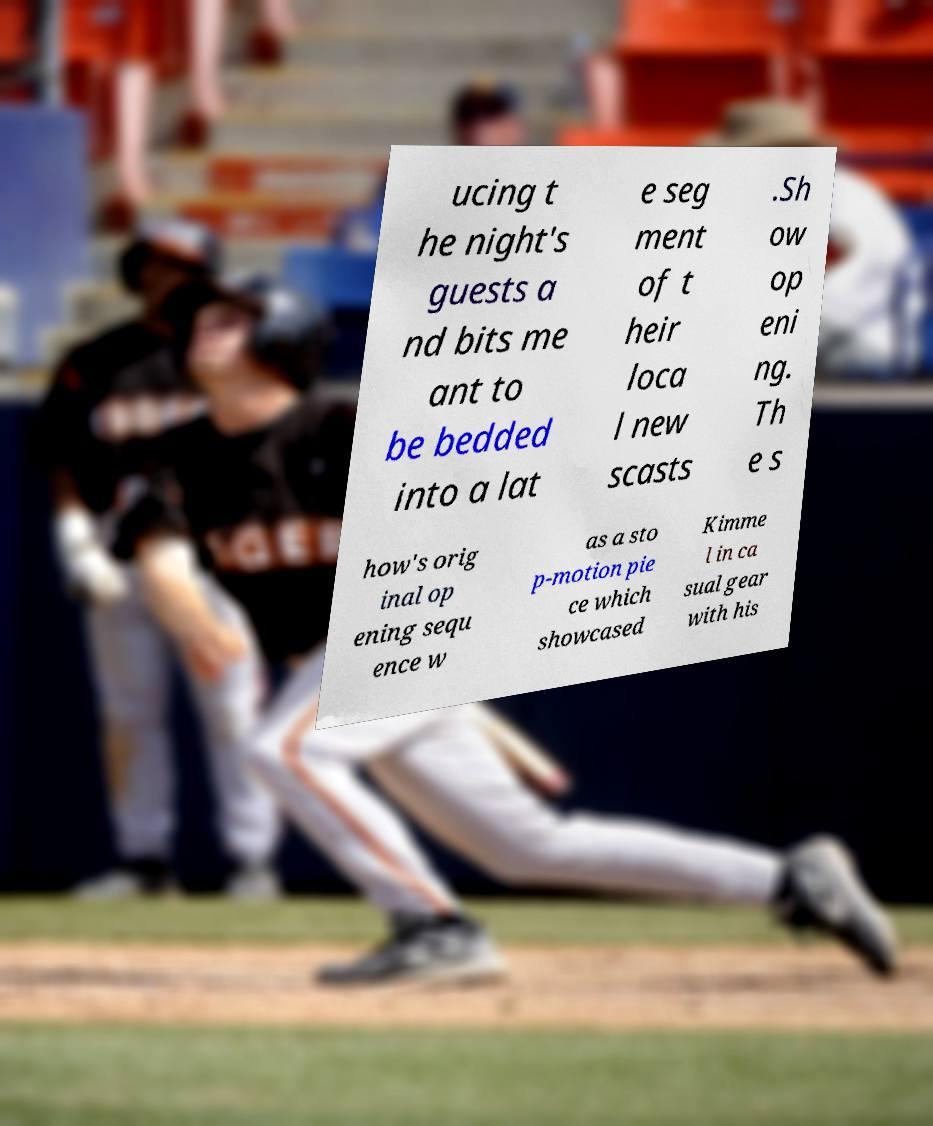Could you assist in decoding the text presented in this image and type it out clearly? ucing t he night's guests a nd bits me ant to be bedded into a lat e seg ment of t heir loca l new scasts .Sh ow op eni ng. Th e s how's orig inal op ening sequ ence w as a sto p-motion pie ce which showcased Kimme l in ca sual gear with his 